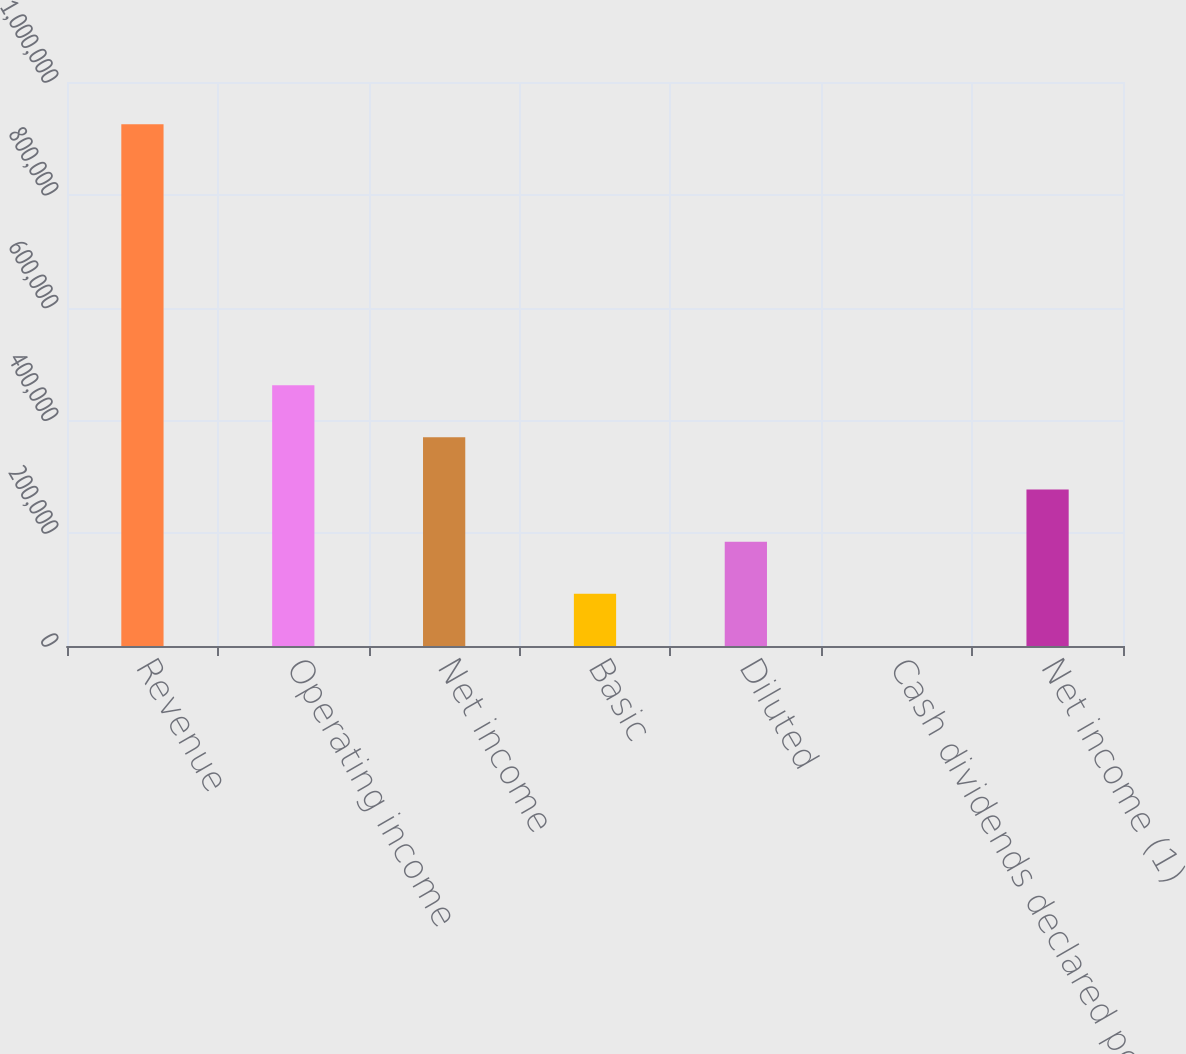<chart> <loc_0><loc_0><loc_500><loc_500><bar_chart><fcel>Revenue<fcel>Operating income<fcel>Net income<fcel>Basic<fcel>Diluted<fcel>Cash dividends declared per<fcel>Net income (1)<nl><fcel>925020<fcel>462510<fcel>370008<fcel>92502.1<fcel>185004<fcel>0.13<fcel>277506<nl></chart> 